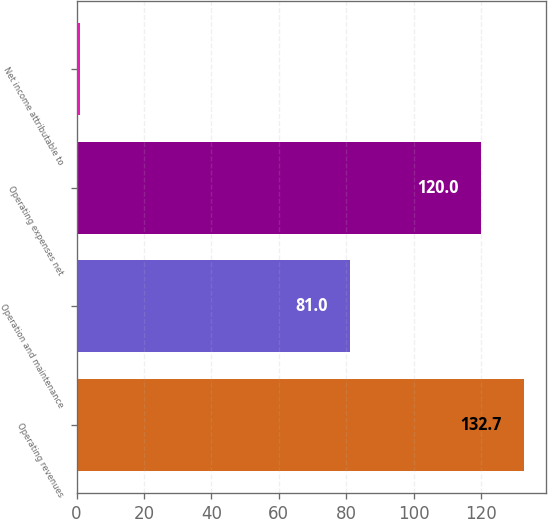Convert chart. <chart><loc_0><loc_0><loc_500><loc_500><bar_chart><fcel>Operating revenues<fcel>Operation and maintenance<fcel>Operating expenses net<fcel>Net income attributable to<nl><fcel>132.7<fcel>81<fcel>120<fcel>1<nl></chart> 